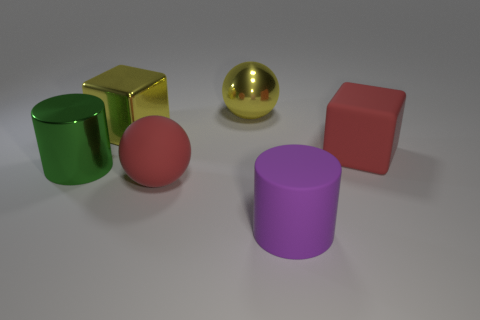What is the color of the other object that is the same shape as the large green object? The color of the object sharing the same cylindrical shape as the large green item is purple. 